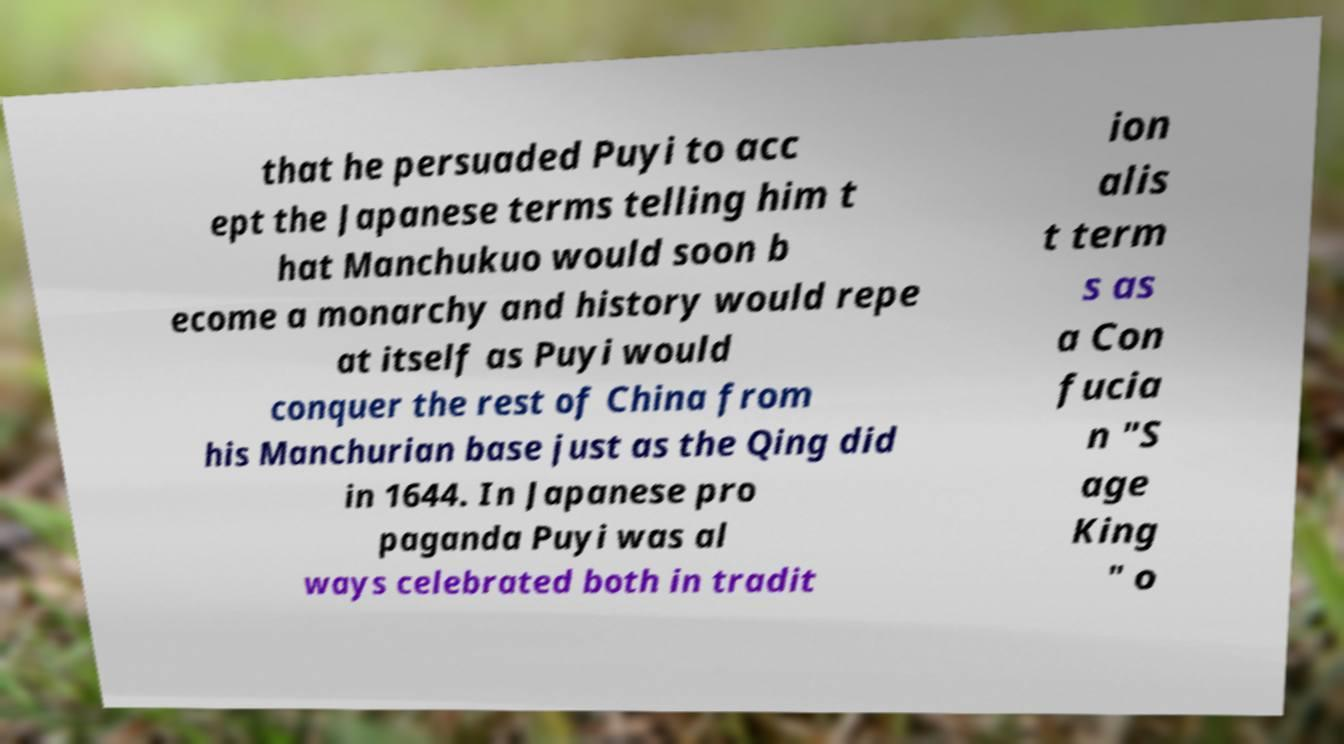Please read and relay the text visible in this image. What does it say? that he persuaded Puyi to acc ept the Japanese terms telling him t hat Manchukuo would soon b ecome a monarchy and history would repe at itself as Puyi would conquer the rest of China from his Manchurian base just as the Qing did in 1644. In Japanese pro paganda Puyi was al ways celebrated both in tradit ion alis t term s as a Con fucia n "S age King " o 